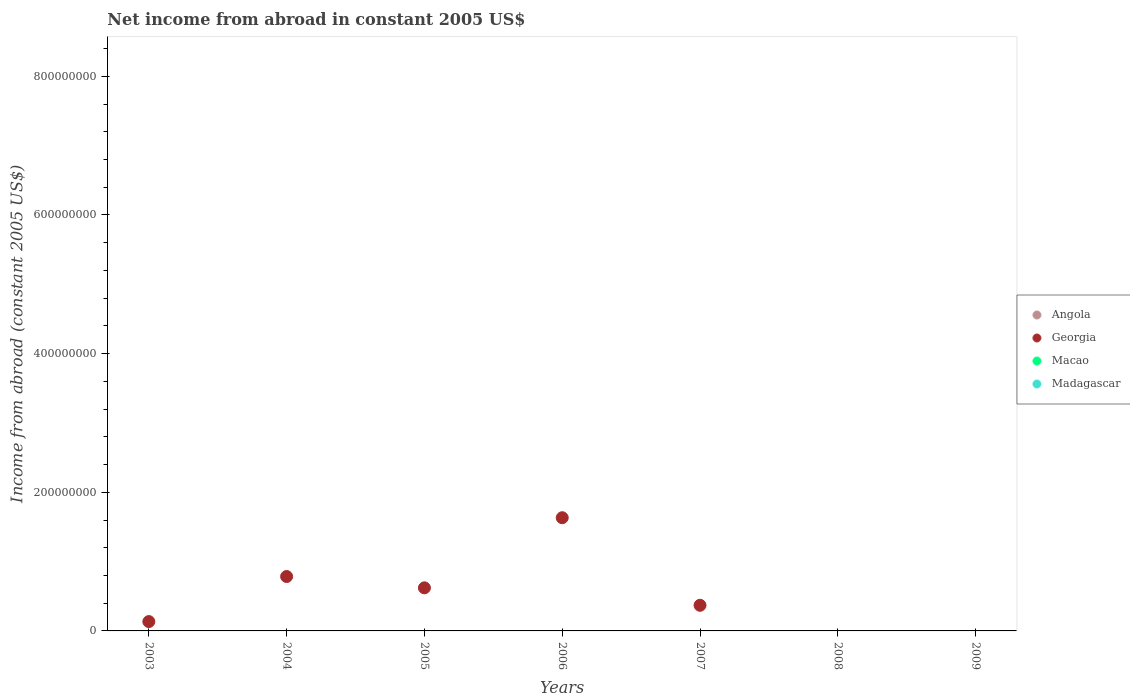How many different coloured dotlines are there?
Your answer should be compact. 1. Is the number of dotlines equal to the number of legend labels?
Your answer should be very brief. No. What is the net income from abroad in Georgia in 2006?
Offer a terse response. 1.63e+08. Across all years, what is the maximum net income from abroad in Georgia?
Your answer should be compact. 1.63e+08. Across all years, what is the minimum net income from abroad in Madagascar?
Your answer should be very brief. 0. What is the total net income from abroad in Georgia in the graph?
Offer a very short reply. 3.54e+08. What is the difference between the net income from abroad in Madagascar in 2004 and the net income from abroad in Angola in 2008?
Ensure brevity in your answer.  0. What is the average net income from abroad in Georgia per year?
Provide a short and direct response. 5.06e+07. What is the ratio of the net income from abroad in Georgia in 2005 to that in 2006?
Keep it short and to the point. 0.38. What is the difference between the highest and the second highest net income from abroad in Georgia?
Your answer should be very brief. 8.48e+07. What is the difference between the highest and the lowest net income from abroad in Georgia?
Your answer should be very brief. 1.63e+08. In how many years, is the net income from abroad in Angola greater than the average net income from abroad in Angola taken over all years?
Ensure brevity in your answer.  0. Is it the case that in every year, the sum of the net income from abroad in Macao and net income from abroad in Georgia  is greater than the sum of net income from abroad in Madagascar and net income from abroad in Angola?
Keep it short and to the point. No. Is it the case that in every year, the sum of the net income from abroad in Georgia and net income from abroad in Angola  is greater than the net income from abroad in Madagascar?
Give a very brief answer. No. Does the net income from abroad in Macao monotonically increase over the years?
Ensure brevity in your answer.  No. Is the net income from abroad in Georgia strictly greater than the net income from abroad in Madagascar over the years?
Ensure brevity in your answer.  No. Is the net income from abroad in Georgia strictly less than the net income from abroad in Macao over the years?
Ensure brevity in your answer.  No. How many dotlines are there?
Ensure brevity in your answer.  1. How many years are there in the graph?
Provide a succinct answer. 7. What is the difference between two consecutive major ticks on the Y-axis?
Make the answer very short. 2.00e+08. Does the graph contain grids?
Your answer should be compact. No. Where does the legend appear in the graph?
Your answer should be very brief. Center right. What is the title of the graph?
Offer a terse response. Net income from abroad in constant 2005 US$. What is the label or title of the Y-axis?
Your answer should be compact. Income from abroad (constant 2005 US$). What is the Income from abroad (constant 2005 US$) in Angola in 2003?
Your answer should be very brief. 0. What is the Income from abroad (constant 2005 US$) in Georgia in 2003?
Your answer should be very brief. 1.35e+07. What is the Income from abroad (constant 2005 US$) of Angola in 2004?
Your response must be concise. 0. What is the Income from abroad (constant 2005 US$) of Georgia in 2004?
Provide a short and direct response. 7.85e+07. What is the Income from abroad (constant 2005 US$) in Macao in 2004?
Your answer should be compact. 0. What is the Income from abroad (constant 2005 US$) of Angola in 2005?
Keep it short and to the point. 0. What is the Income from abroad (constant 2005 US$) of Georgia in 2005?
Provide a short and direct response. 6.21e+07. What is the Income from abroad (constant 2005 US$) of Madagascar in 2005?
Your answer should be compact. 0. What is the Income from abroad (constant 2005 US$) of Georgia in 2006?
Make the answer very short. 1.63e+08. What is the Income from abroad (constant 2005 US$) in Macao in 2006?
Offer a terse response. 0. What is the Income from abroad (constant 2005 US$) in Angola in 2007?
Your response must be concise. 0. What is the Income from abroad (constant 2005 US$) in Georgia in 2007?
Your answer should be compact. 3.70e+07. What is the Income from abroad (constant 2005 US$) in Madagascar in 2007?
Your response must be concise. 0. What is the Income from abroad (constant 2005 US$) in Angola in 2008?
Ensure brevity in your answer.  0. What is the Income from abroad (constant 2005 US$) in Macao in 2008?
Give a very brief answer. 0. What is the Income from abroad (constant 2005 US$) in Angola in 2009?
Your answer should be compact. 0. What is the Income from abroad (constant 2005 US$) in Macao in 2009?
Make the answer very short. 0. What is the Income from abroad (constant 2005 US$) of Madagascar in 2009?
Provide a succinct answer. 0. Across all years, what is the maximum Income from abroad (constant 2005 US$) of Georgia?
Your response must be concise. 1.63e+08. What is the total Income from abroad (constant 2005 US$) in Georgia in the graph?
Your response must be concise. 3.54e+08. What is the total Income from abroad (constant 2005 US$) in Madagascar in the graph?
Give a very brief answer. 0. What is the difference between the Income from abroad (constant 2005 US$) of Georgia in 2003 and that in 2004?
Make the answer very short. -6.50e+07. What is the difference between the Income from abroad (constant 2005 US$) of Georgia in 2003 and that in 2005?
Give a very brief answer. -4.87e+07. What is the difference between the Income from abroad (constant 2005 US$) in Georgia in 2003 and that in 2006?
Your answer should be very brief. -1.50e+08. What is the difference between the Income from abroad (constant 2005 US$) of Georgia in 2003 and that in 2007?
Your answer should be very brief. -2.35e+07. What is the difference between the Income from abroad (constant 2005 US$) of Georgia in 2004 and that in 2005?
Make the answer very short. 1.63e+07. What is the difference between the Income from abroad (constant 2005 US$) in Georgia in 2004 and that in 2006?
Your response must be concise. -8.48e+07. What is the difference between the Income from abroad (constant 2005 US$) of Georgia in 2004 and that in 2007?
Ensure brevity in your answer.  4.15e+07. What is the difference between the Income from abroad (constant 2005 US$) in Georgia in 2005 and that in 2006?
Your response must be concise. -1.01e+08. What is the difference between the Income from abroad (constant 2005 US$) in Georgia in 2005 and that in 2007?
Give a very brief answer. 2.52e+07. What is the difference between the Income from abroad (constant 2005 US$) in Georgia in 2006 and that in 2007?
Offer a terse response. 1.26e+08. What is the average Income from abroad (constant 2005 US$) in Angola per year?
Your response must be concise. 0. What is the average Income from abroad (constant 2005 US$) in Georgia per year?
Offer a terse response. 5.06e+07. What is the average Income from abroad (constant 2005 US$) in Macao per year?
Your answer should be compact. 0. What is the average Income from abroad (constant 2005 US$) of Madagascar per year?
Keep it short and to the point. 0. What is the ratio of the Income from abroad (constant 2005 US$) of Georgia in 2003 to that in 2004?
Keep it short and to the point. 0.17. What is the ratio of the Income from abroad (constant 2005 US$) in Georgia in 2003 to that in 2005?
Your answer should be compact. 0.22. What is the ratio of the Income from abroad (constant 2005 US$) of Georgia in 2003 to that in 2006?
Your answer should be compact. 0.08. What is the ratio of the Income from abroad (constant 2005 US$) in Georgia in 2003 to that in 2007?
Your answer should be very brief. 0.36. What is the ratio of the Income from abroad (constant 2005 US$) in Georgia in 2004 to that in 2005?
Make the answer very short. 1.26. What is the ratio of the Income from abroad (constant 2005 US$) of Georgia in 2004 to that in 2006?
Offer a terse response. 0.48. What is the ratio of the Income from abroad (constant 2005 US$) of Georgia in 2004 to that in 2007?
Your answer should be very brief. 2.12. What is the ratio of the Income from abroad (constant 2005 US$) of Georgia in 2005 to that in 2006?
Your answer should be very brief. 0.38. What is the ratio of the Income from abroad (constant 2005 US$) of Georgia in 2005 to that in 2007?
Your answer should be very brief. 1.68. What is the ratio of the Income from abroad (constant 2005 US$) of Georgia in 2006 to that in 2007?
Your response must be concise. 4.42. What is the difference between the highest and the second highest Income from abroad (constant 2005 US$) of Georgia?
Make the answer very short. 8.48e+07. What is the difference between the highest and the lowest Income from abroad (constant 2005 US$) in Georgia?
Offer a terse response. 1.63e+08. 